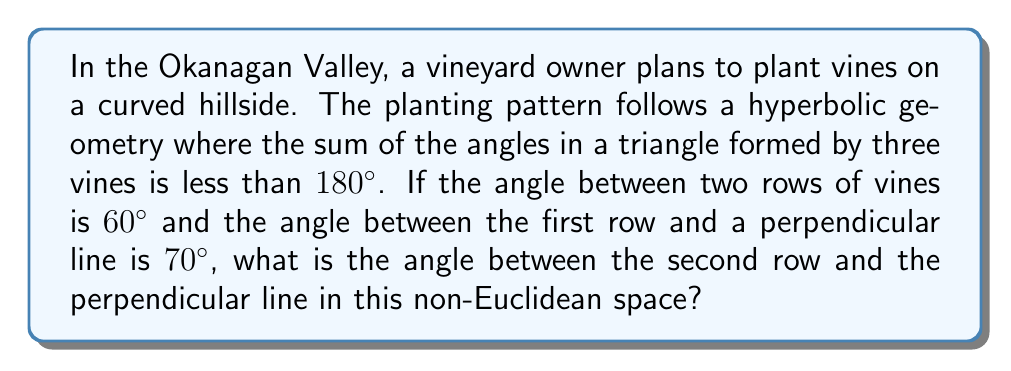Could you help me with this problem? Let's approach this step-by-step:

1) In hyperbolic geometry, the sum of angles in a triangle is less than 180°. Let's call the unknown angle $x$.

2) We can visualize the problem as follows:
   [asy]
   import geometry;
   size(200);
   pair A=(0,0), B=(100,0), C=(50,86.6);
   draw(A--B--C--A);
   draw(A--(50,-86.6),dashed);
   label("70°",A,SW);
   label("60°",C,N);
   label("$x$°",B,SE);
   [/asy]

3) In Euclidean geometry, we would expect:
   $70° + 60° + x = 180°$
   $x = 50°$

4) However, in hyperbolic geometry, the sum is less than 180°. Let's say it's $180° - \delta$, where $\delta > 0$.

5) So, we have:
   $70° + 60° + x = 180° - \delta$

6) Solving for $x$:
   $x = 50° - \delta$

7) This means the angle $x$ will be less than 50°.

8) The exact value of $\delta$ depends on the specific curvature of the hyperbolic space, which isn't provided in the question. However, we can conclude that $x < 50°$.
Answer: $x < 50°$ 